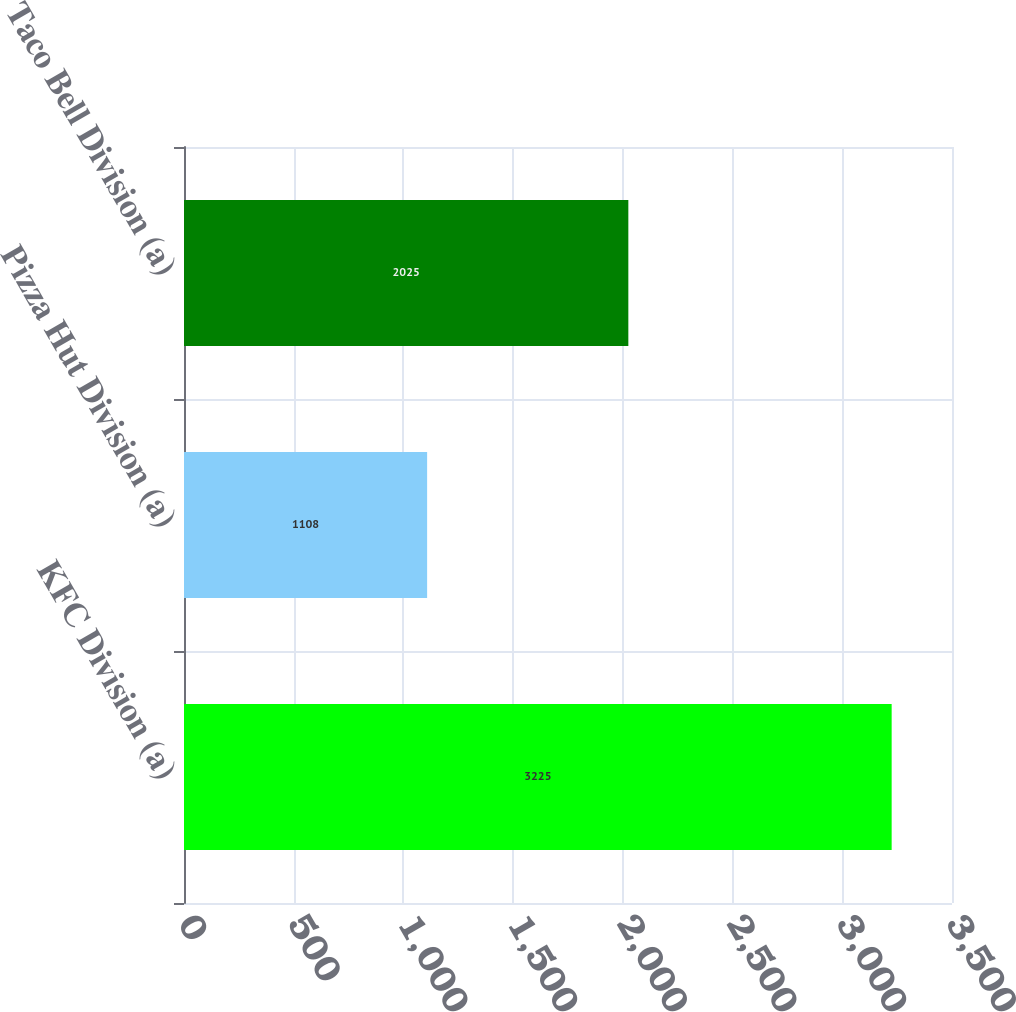<chart> <loc_0><loc_0><loc_500><loc_500><bar_chart><fcel>KFC Division (a)<fcel>Pizza Hut Division (a)<fcel>Taco Bell Division (a)<nl><fcel>3225<fcel>1108<fcel>2025<nl></chart> 